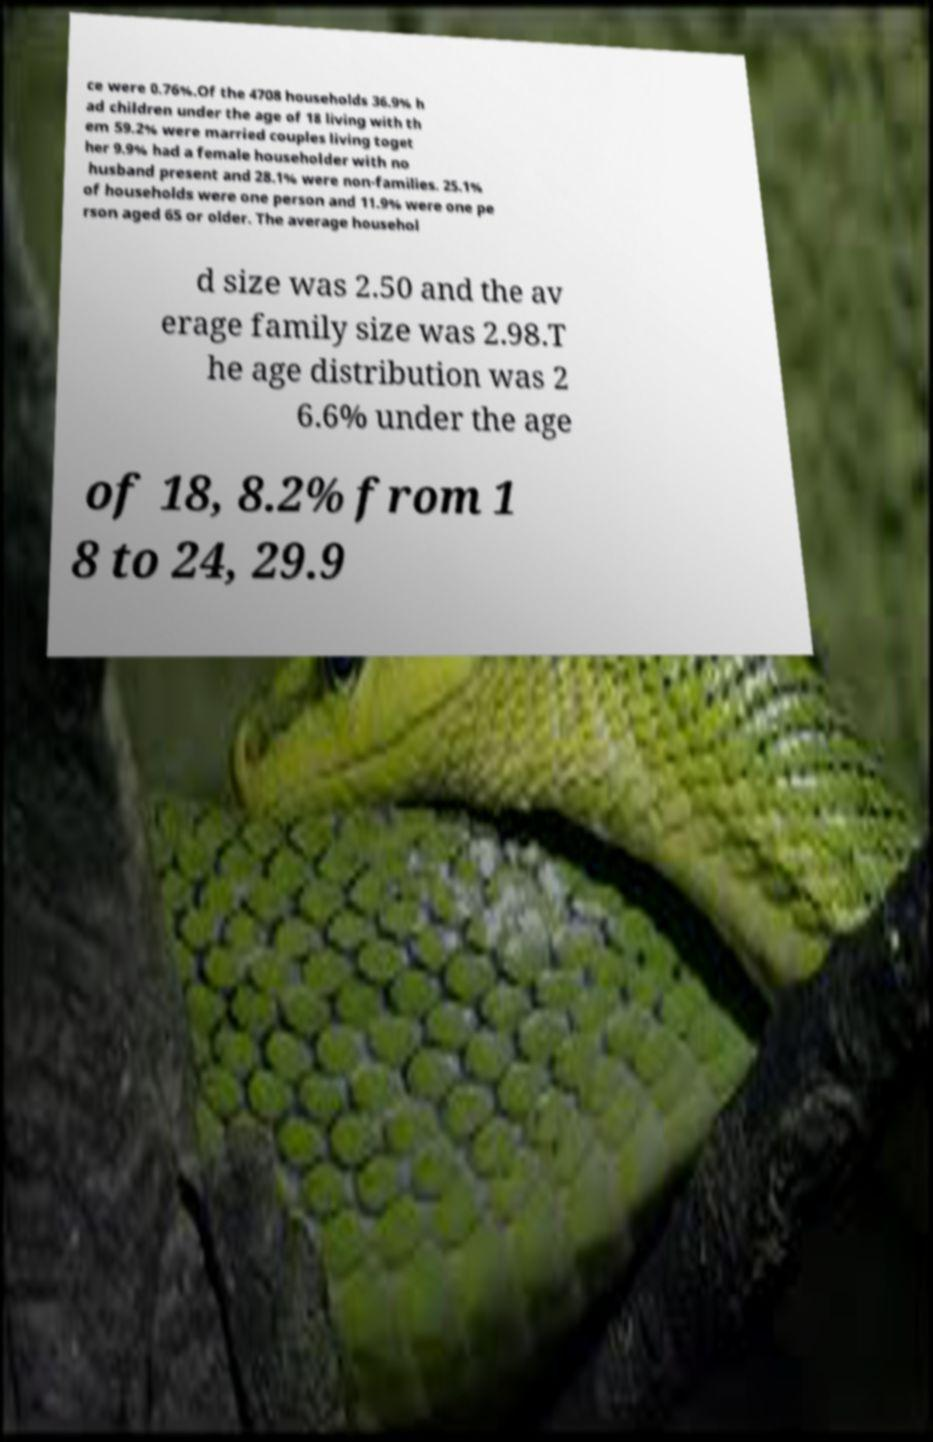Please identify and transcribe the text found in this image. ce were 0.76%.Of the 4708 households 36.9% h ad children under the age of 18 living with th em 59.2% were married couples living toget her 9.9% had a female householder with no husband present and 28.1% were non-families. 25.1% of households were one person and 11.9% were one pe rson aged 65 or older. The average househol d size was 2.50 and the av erage family size was 2.98.T he age distribution was 2 6.6% under the age of 18, 8.2% from 1 8 to 24, 29.9 